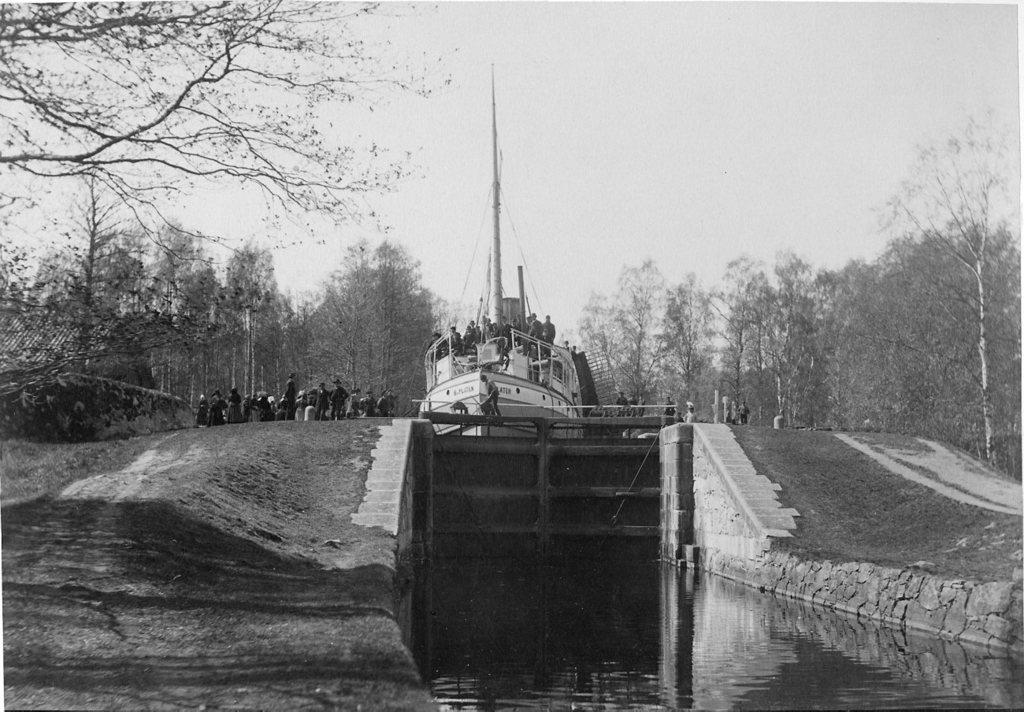What is the color scheme of the image? The image is black and white. What can be seen on the water in the image? There is a gate in the water. What type of structure is the group of people standing on? The group of people is standing on a ship. What is visible in the background of the image? There are trees and the sky visible in the background of the image. What type of paste is being used by the people on the ship in the image? There is no indication of any paste being used by the people on the ship in the image. What direction is the current flowing in the image? There is no visible current in the image, as it is a still photograph. 